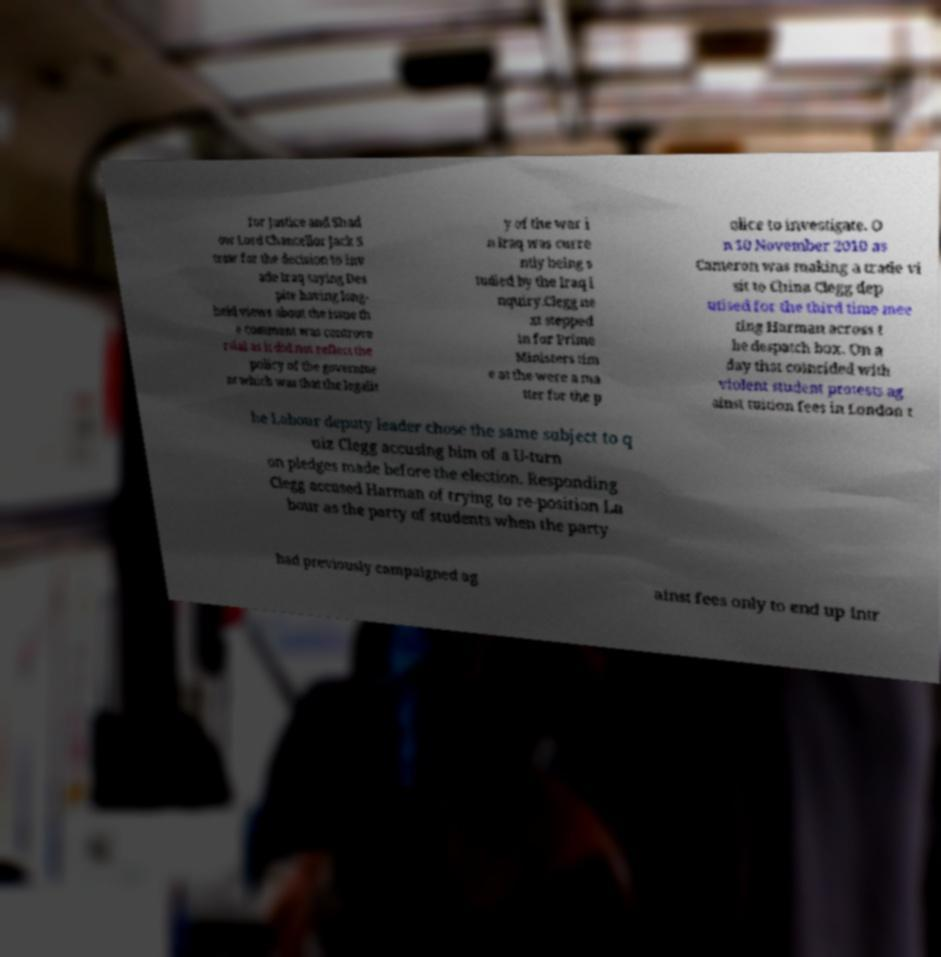Can you accurately transcribe the text from the provided image for me? for Justice and Shad ow Lord Chancellor Jack S traw for the decision to inv ade Iraq saying Des pite having long- held views about the issue th e comment was controve rsial as it did not reflect the policy of the governme nt which was that the legalit y of the war i n Iraq was curre ntly being s tudied by the Iraq i nquiry.Clegg ne xt stepped in for Prime Ministers tim e at the were a ma tter for the p olice to investigate. O n 10 November 2010 as Cameron was making a trade vi sit to China Clegg dep utised for the third time mee ting Harman across t he despatch box. On a day that coincided with violent student protests ag ainst tuition fees in London t he Labour deputy leader chose the same subject to q uiz Clegg accusing him of a U-turn on pledges made before the election. Responding Clegg accused Harman of trying to re-position La bour as the party of students when the party had previously campaigned ag ainst fees only to end up intr 